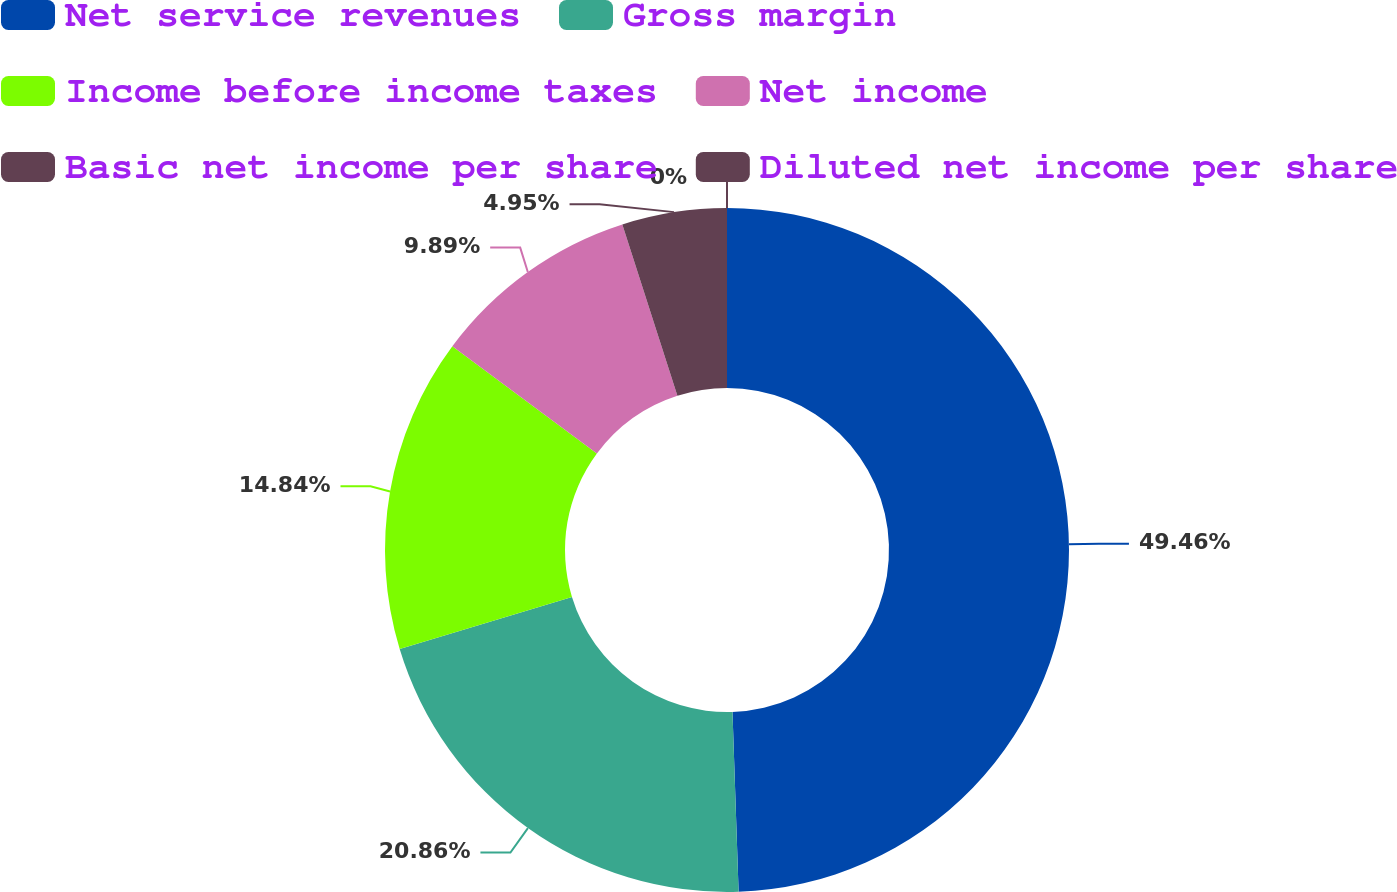Convert chart to OTSL. <chart><loc_0><loc_0><loc_500><loc_500><pie_chart><fcel>Net service revenues<fcel>Gross margin<fcel>Income before income taxes<fcel>Net income<fcel>Basic net income per share<fcel>Diluted net income per share<nl><fcel>49.46%<fcel>20.86%<fcel>14.84%<fcel>9.89%<fcel>4.95%<fcel>0.0%<nl></chart> 